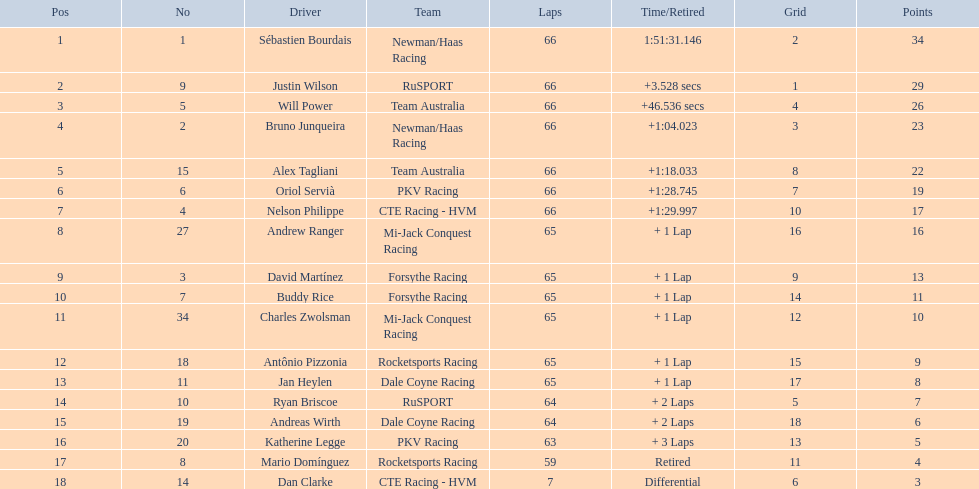Who had more drivers representing their nation, the united states or germany? Tie. Would you mind parsing the complete table? {'header': ['Pos', 'No', 'Driver', 'Team', 'Laps', 'Time/Retired', 'Grid', 'Points'], 'rows': [['1', '1', 'Sébastien Bourdais', 'Newman/Haas Racing', '66', '1:51:31.146', '2', '34'], ['2', '9', 'Justin Wilson', 'RuSPORT', '66', '+3.528 secs', '1', '29'], ['3', '5', 'Will Power', 'Team Australia', '66', '+46.536 secs', '4', '26'], ['4', '2', 'Bruno Junqueira', 'Newman/Haas Racing', '66', '+1:04.023', '3', '23'], ['5', '15', 'Alex Tagliani', 'Team Australia', '66', '+1:18.033', '8', '22'], ['6', '6', 'Oriol Servià', 'PKV Racing', '66', '+1:28.745', '7', '19'], ['7', '4', 'Nelson Philippe', 'CTE Racing - HVM', '66', '+1:29.997', '10', '17'], ['8', '27', 'Andrew Ranger', 'Mi-Jack Conquest Racing', '65', '+ 1 Lap', '16', '16'], ['9', '3', 'David Martínez', 'Forsythe Racing', '65', '+ 1 Lap', '9', '13'], ['10', '7', 'Buddy Rice', 'Forsythe Racing', '65', '+ 1 Lap', '14', '11'], ['11', '34', 'Charles Zwolsman', 'Mi-Jack Conquest Racing', '65', '+ 1 Lap', '12', '10'], ['12', '18', 'Antônio Pizzonia', 'Rocketsports Racing', '65', '+ 1 Lap', '15', '9'], ['13', '11', 'Jan Heylen', 'Dale Coyne Racing', '65', '+ 1 Lap', '17', '8'], ['14', '10', 'Ryan Briscoe', 'RuSPORT', '64', '+ 2 Laps', '5', '7'], ['15', '19', 'Andreas Wirth', 'Dale Coyne Racing', '64', '+ 2 Laps', '18', '6'], ['16', '20', 'Katherine Legge', 'PKV Racing', '63', '+ 3 Laps', '13', '5'], ['17', '8', 'Mario Domínguez', 'Rocketsports Racing', '59', 'Retired', '11', '4'], ['18', '14', 'Dan Clarke', 'CTE Racing - HVM', '7', 'Differential', '6', '3']]} 